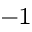<formula> <loc_0><loc_0><loc_500><loc_500>^ { - 1 }</formula> 